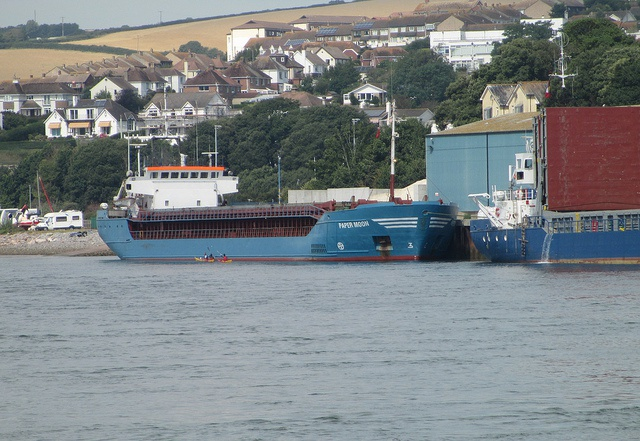Describe the objects in this image and their specific colors. I can see boat in darkgray, gray, black, and blue tones, boat in darkgray, blue, gray, and navy tones, truck in darkgray, lightgray, and gray tones, people in darkgray, gray, maroon, and brown tones, and people in darkgray, brown, and purple tones in this image. 